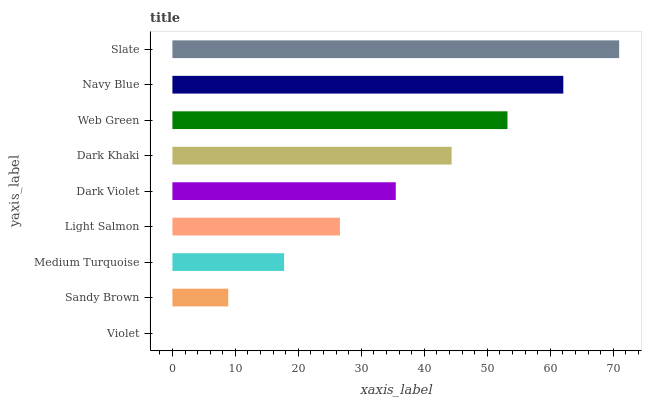Is Violet the minimum?
Answer yes or no. Yes. Is Slate the maximum?
Answer yes or no. Yes. Is Sandy Brown the minimum?
Answer yes or no. No. Is Sandy Brown the maximum?
Answer yes or no. No. Is Sandy Brown greater than Violet?
Answer yes or no. Yes. Is Violet less than Sandy Brown?
Answer yes or no. Yes. Is Violet greater than Sandy Brown?
Answer yes or no. No. Is Sandy Brown less than Violet?
Answer yes or no. No. Is Dark Violet the high median?
Answer yes or no. Yes. Is Dark Violet the low median?
Answer yes or no. Yes. Is Slate the high median?
Answer yes or no. No. Is Slate the low median?
Answer yes or no. No. 